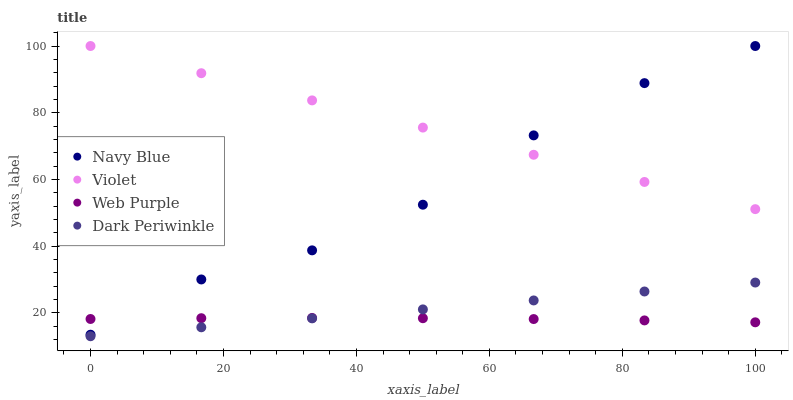Does Web Purple have the minimum area under the curve?
Answer yes or no. Yes. Does Violet have the maximum area under the curve?
Answer yes or no. Yes. Does Dark Periwinkle have the minimum area under the curve?
Answer yes or no. No. Does Dark Periwinkle have the maximum area under the curve?
Answer yes or no. No. Is Dark Periwinkle the smoothest?
Answer yes or no. Yes. Is Navy Blue the roughest?
Answer yes or no. Yes. Is Web Purple the smoothest?
Answer yes or no. No. Is Web Purple the roughest?
Answer yes or no. No. Does Dark Periwinkle have the lowest value?
Answer yes or no. Yes. Does Web Purple have the lowest value?
Answer yes or no. No. Does Violet have the highest value?
Answer yes or no. Yes. Does Dark Periwinkle have the highest value?
Answer yes or no. No. Is Web Purple less than Violet?
Answer yes or no. Yes. Is Violet greater than Web Purple?
Answer yes or no. Yes. Does Navy Blue intersect Web Purple?
Answer yes or no. Yes. Is Navy Blue less than Web Purple?
Answer yes or no. No. Is Navy Blue greater than Web Purple?
Answer yes or no. No. Does Web Purple intersect Violet?
Answer yes or no. No. 